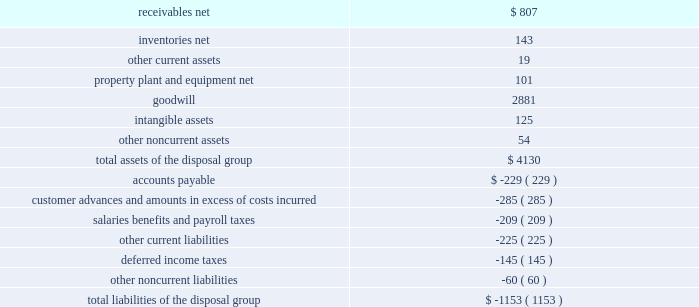Divestiture of the information systems & global solutions business on august 16 , 2016 , we completed the previously announced divestiture of the is&gs business , which merged with a subsidiary of leidos , in a reverse morris trust transaction ( the 201ctransaction 201d ) .
The transaction was completed in a multi- step process pursuant to which we initially contributed the is&gs business to abacus innovations corporation ( abacus ) , a wholly owned subsidiary of lockheed martin created to facilitate the transaction , and the common stock of abacus was distributed to participating lockheed martin stockholders through an exchange offer .
Under the terms of the exchange offer , lockheed martin stockholders had the option to exchange shares of lockheed martin common stock for shares of abacus common stock .
At the conclusion of the exchange offer , all shares of abacus common stock were exchanged for 9369694 shares of lockheed martin common stock held by lockheed martin stockholders that elected to participate in the exchange .
The shares of lockheed martin common stock that were exchanged and accepted were retired , reducing the number of shares of our common stock outstanding by approximately 3% ( 3 % ) .
Following the exchange offer , abacus merged with a subsidiary of leidos , with abacus continuing as the surviving corporation and a wholly-owned subsidiary of leidos .
As part of the merger , each share of abacus common stock was automatically converted into one share of leidos common stock .
We did not receive any shares of leidos common stock as part of the transaction and do not hold any shares of leidos or abacus common stock following the transaction .
Based on an opinion of outside tax counsel , subject to customary qualifications and based on factual representations , the exchange offer and merger will qualify as tax-free transactions to lockheed martin and its stockholders , except to the extent that cash was paid to lockheed martin stockholders in lieu of fractional shares .
In connection with the transaction , abacus borrowed an aggregate principal amount of approximately $ 1.84 billion under term loan facilities with third party financial institutions , the proceeds of which were used to make a one-time special cash payment of $ 1.80 billion to lockheed martin and to pay associated borrowing fees and expenses .
The entire special cash payment was used to repay debt , pay dividends and repurchase stock during the third and fourth quarters of 2016 .
The obligations under the abacus term loan facilities were guaranteed by leidos as part of the transaction .
As a result of the transaction , we recognized a net gain of approximately $ 1.2 billion .
The net gain represents the $ 2.5 billion fair value of the shares of lockheed martin common stock exchanged and retired as part of the exchange offer , plus the $ 1.8 billion one-time special cash payment , less the net book value of the is&gs business of about $ 3.0 billion at august 16 , 2016 and other adjustments of about $ 100 million .
The final gain is subject to certain post-closing adjustments , including final working capital , indemnification , and tax adjustments , which we expect to complete in 2017 .
We classified the operating results of our is&gs business as discontinued operations in our consolidated financial statements in accordance with u.s .
Gaap , as the divestiture of this business represented a strategic shift that had a major effect on our operations and financial results .
However , the cash flows generated by the is&gs business have not been reclassified in our consolidated statements of cash flows as we retained this cash as part of the transaction .
The carrying amounts of major classes of the is&gs business assets and liabilities that were classified as assets and liabilities of discontinued operations as of december 31 , 2015 are as follows ( in millions ) : .

What percentage of the total assets of the disposal group were attributable to receivables net? 
Computations: (807 / 4130)
Answer: 0.1954. 